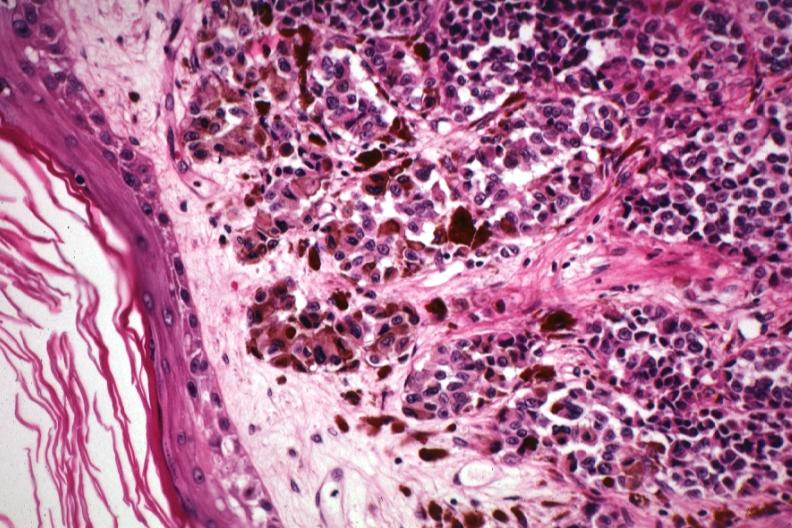where is this?
Answer the question using a single word or phrase. Skin 